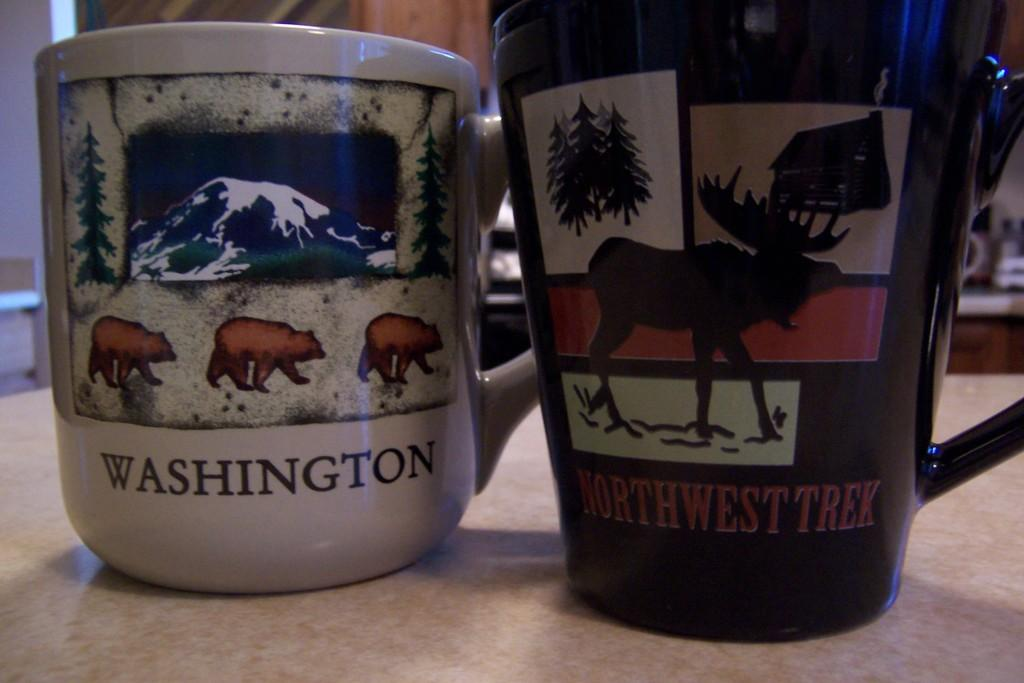How many mugs are visible in the image? There are two mugs in the image. Where are the mugs located? The mugs are on a table. What type of straw is used to stir the contents of the mugs in the image? There are no straws present in the image; only the two mugs are visible. 